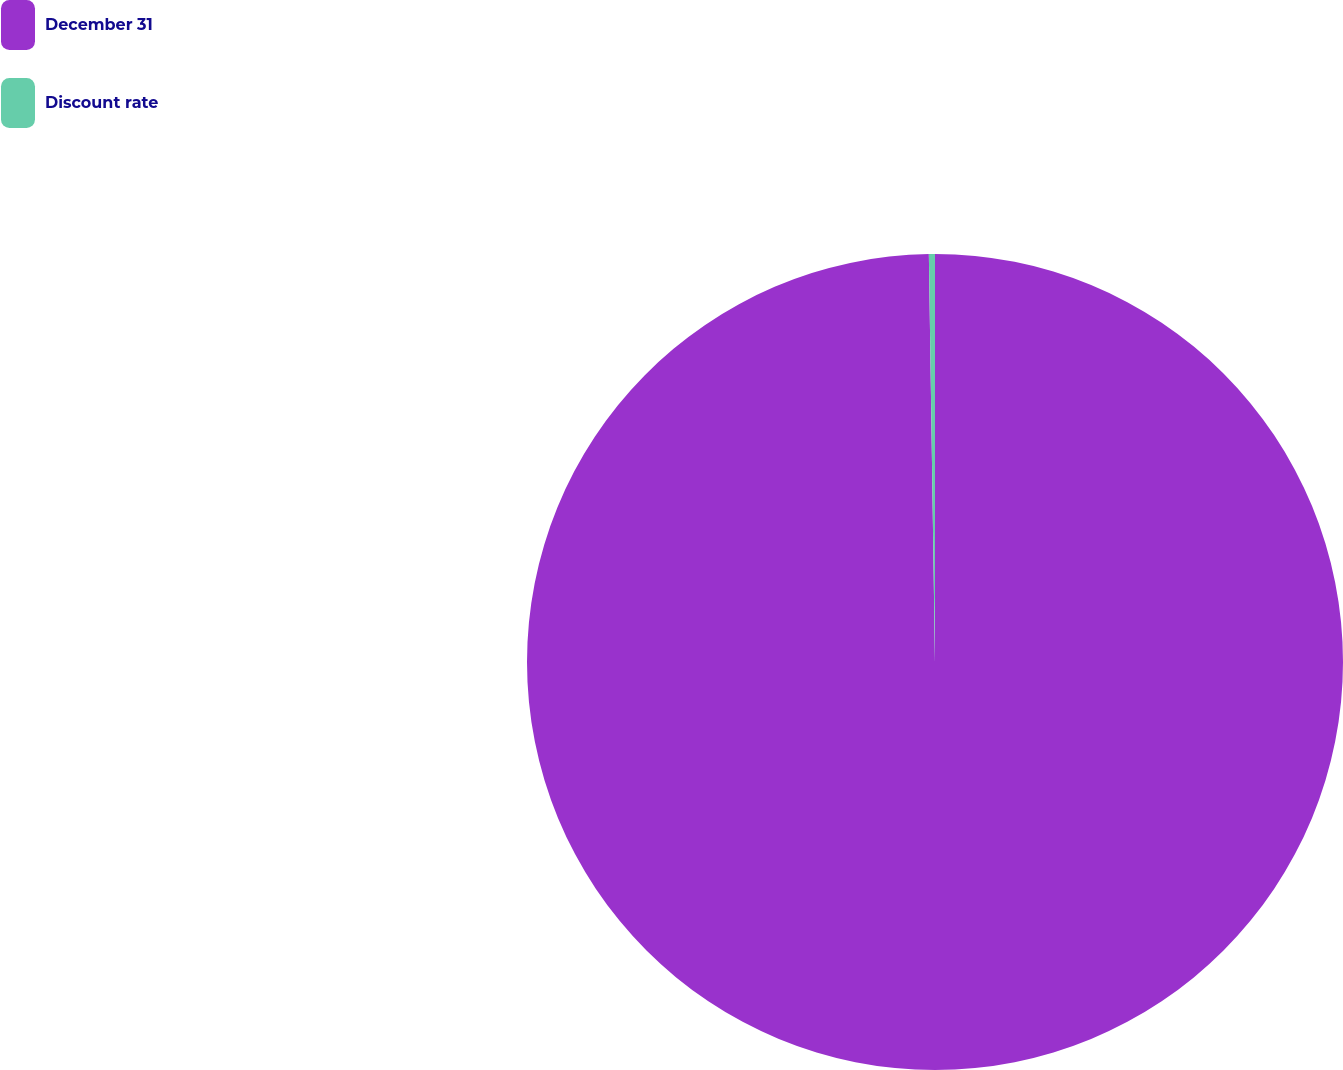Convert chart to OTSL. <chart><loc_0><loc_0><loc_500><loc_500><pie_chart><fcel>December 31<fcel>Discount rate<nl><fcel>99.76%<fcel>0.24%<nl></chart> 